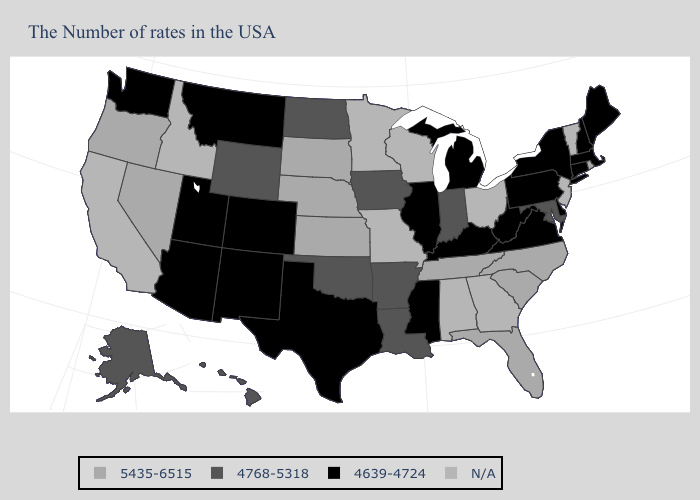What is the value of West Virginia?
Write a very short answer. 4639-4724. Name the states that have a value in the range 5435-6515?
Write a very short answer. Rhode Island, North Carolina, South Carolina, Florida, Tennessee, Kansas, Nebraska, South Dakota, Nevada, Oregon. Name the states that have a value in the range 4768-5318?
Short answer required. Maryland, Indiana, Louisiana, Arkansas, Iowa, Oklahoma, North Dakota, Wyoming, Alaska, Hawaii. What is the highest value in the Northeast ?
Be succinct. 5435-6515. Does the map have missing data?
Keep it brief. Yes. Is the legend a continuous bar?
Quick response, please. No. Name the states that have a value in the range 4639-4724?
Quick response, please. Maine, Massachusetts, New Hampshire, Connecticut, New York, Delaware, Pennsylvania, Virginia, West Virginia, Michigan, Kentucky, Illinois, Mississippi, Texas, Colorado, New Mexico, Utah, Montana, Arizona, Washington. What is the lowest value in states that border Arizona?
Quick response, please. 4639-4724. What is the highest value in states that border Oklahoma?
Concise answer only. 5435-6515. Does Maine have the lowest value in the Northeast?
Concise answer only. Yes. Is the legend a continuous bar?
Give a very brief answer. No. Which states have the lowest value in the Northeast?
Concise answer only. Maine, Massachusetts, New Hampshire, Connecticut, New York, Pennsylvania. Which states have the lowest value in the Northeast?
Short answer required. Maine, Massachusetts, New Hampshire, Connecticut, New York, Pennsylvania. Name the states that have a value in the range 5435-6515?
Write a very short answer. Rhode Island, North Carolina, South Carolina, Florida, Tennessee, Kansas, Nebraska, South Dakota, Nevada, Oregon. What is the value of Connecticut?
Be succinct. 4639-4724. 